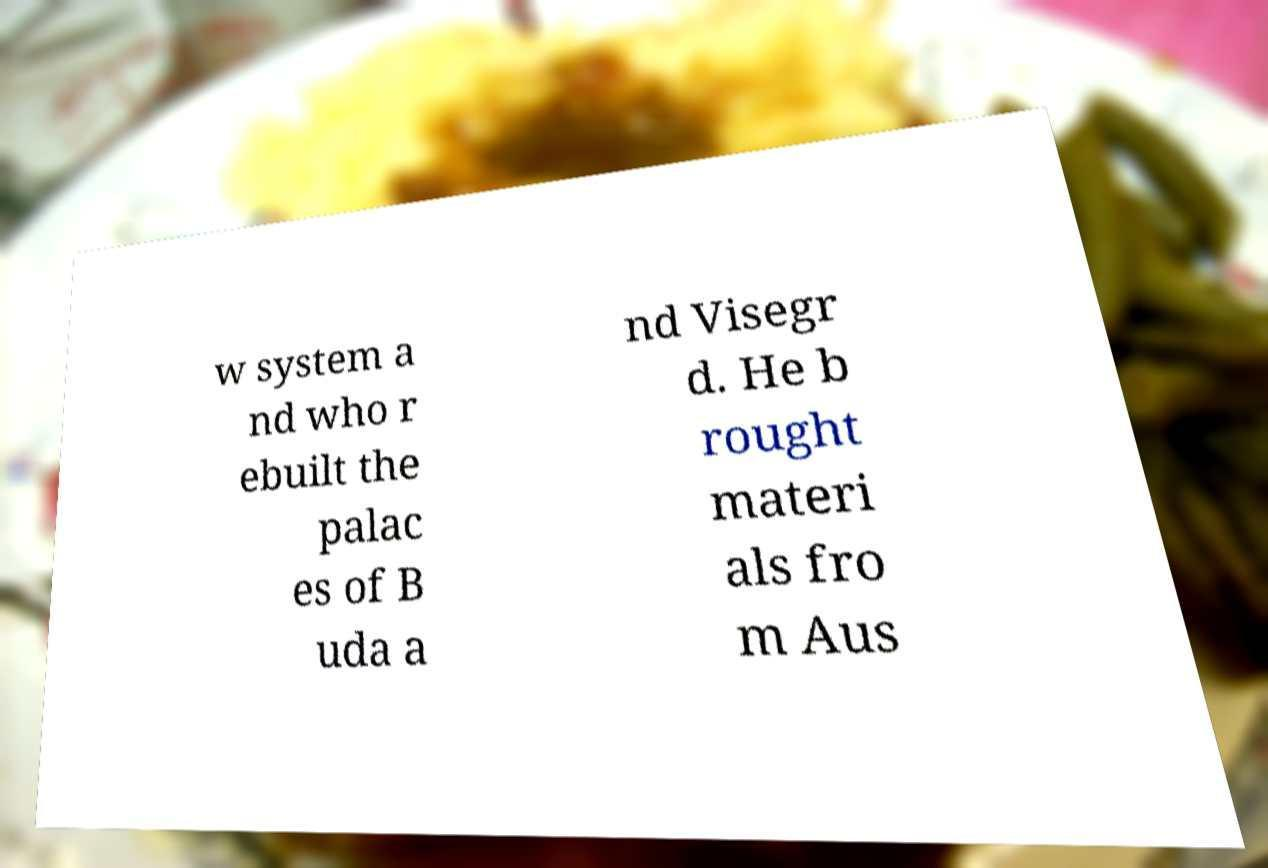What messages or text are displayed in this image? I need them in a readable, typed format. w system a nd who r ebuilt the palac es of B uda a nd Visegr d. He b rought materi als fro m Aus 